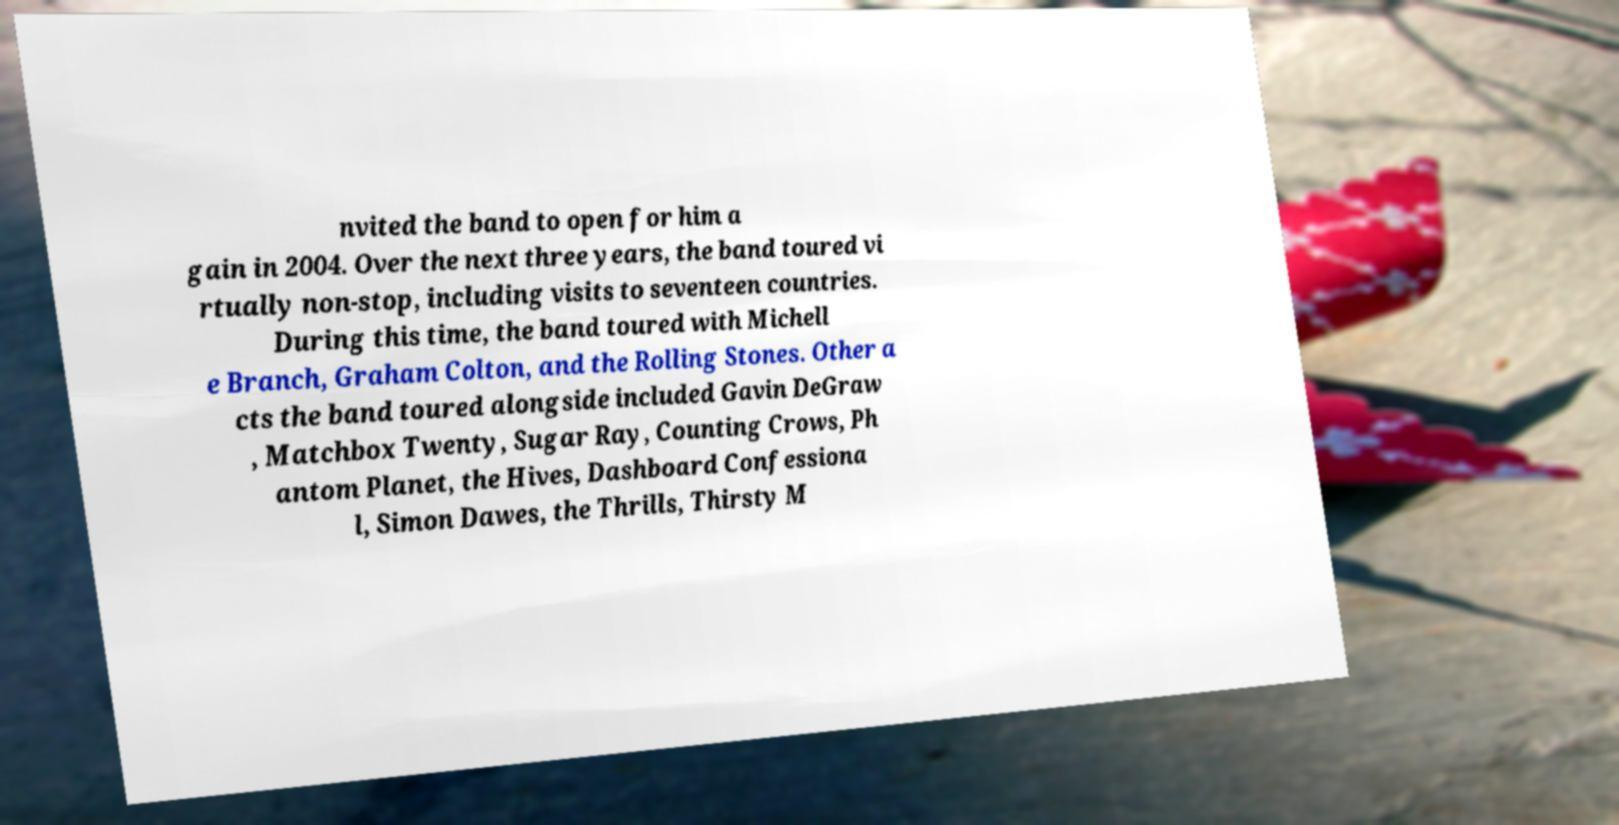There's text embedded in this image that I need extracted. Can you transcribe it verbatim? nvited the band to open for him a gain in 2004. Over the next three years, the band toured vi rtually non-stop, including visits to seventeen countries. During this time, the band toured with Michell e Branch, Graham Colton, and the Rolling Stones. Other a cts the band toured alongside included Gavin DeGraw , Matchbox Twenty, Sugar Ray, Counting Crows, Ph antom Planet, the Hives, Dashboard Confessiona l, Simon Dawes, the Thrills, Thirsty M 